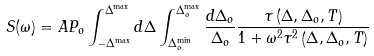Convert formula to latex. <formula><loc_0><loc_0><loc_500><loc_500>S ( \omega ) = A P _ { o } \int ^ { \Delta ^ { \max } } _ { - \Delta ^ { \max } } d \Delta \int ^ { \Delta _ { o } ^ { \max } } _ { \Delta _ { o } ^ { \min } } \frac { d \Delta _ { o } } { \Delta _ { o } } \frac { \tau \left ( \Delta , \Delta _ { o } , T \right ) } { 1 + \omega ^ { 2 } \tau ^ { 2 } \left ( \Delta , \Delta _ { o } , T \right ) }</formula> 